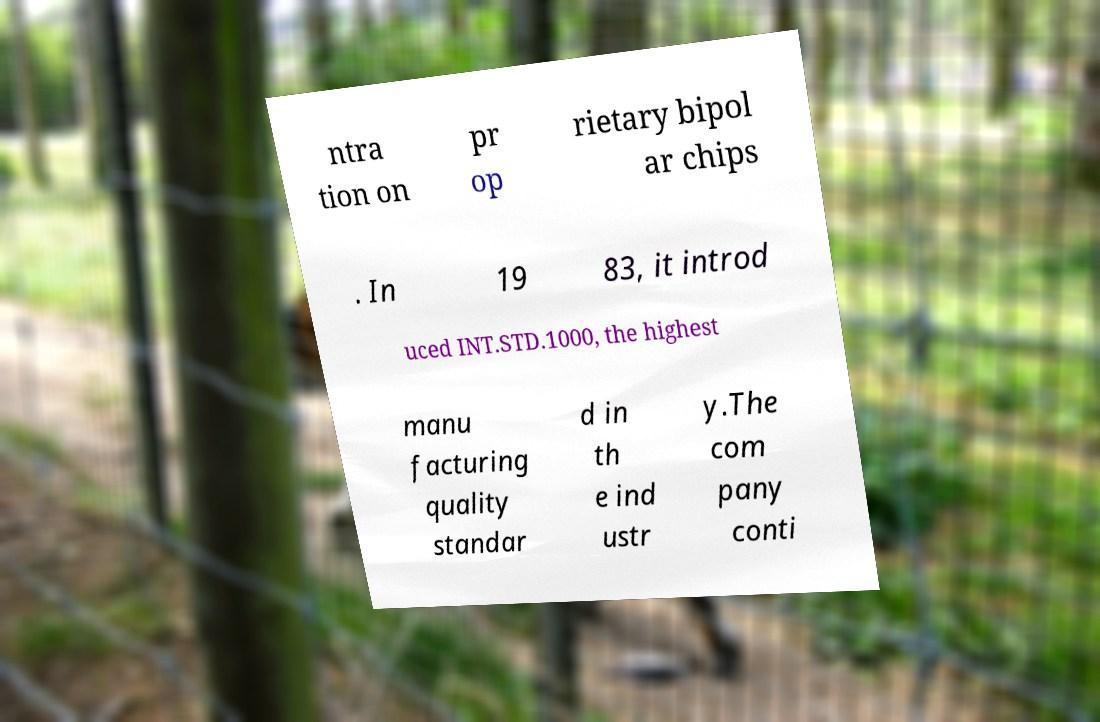Could you assist in decoding the text presented in this image and type it out clearly? ntra tion on pr op rietary bipol ar chips . In 19 83, it introd uced INT.STD.1000, the highest manu facturing quality standar d in th e ind ustr y.The com pany conti 